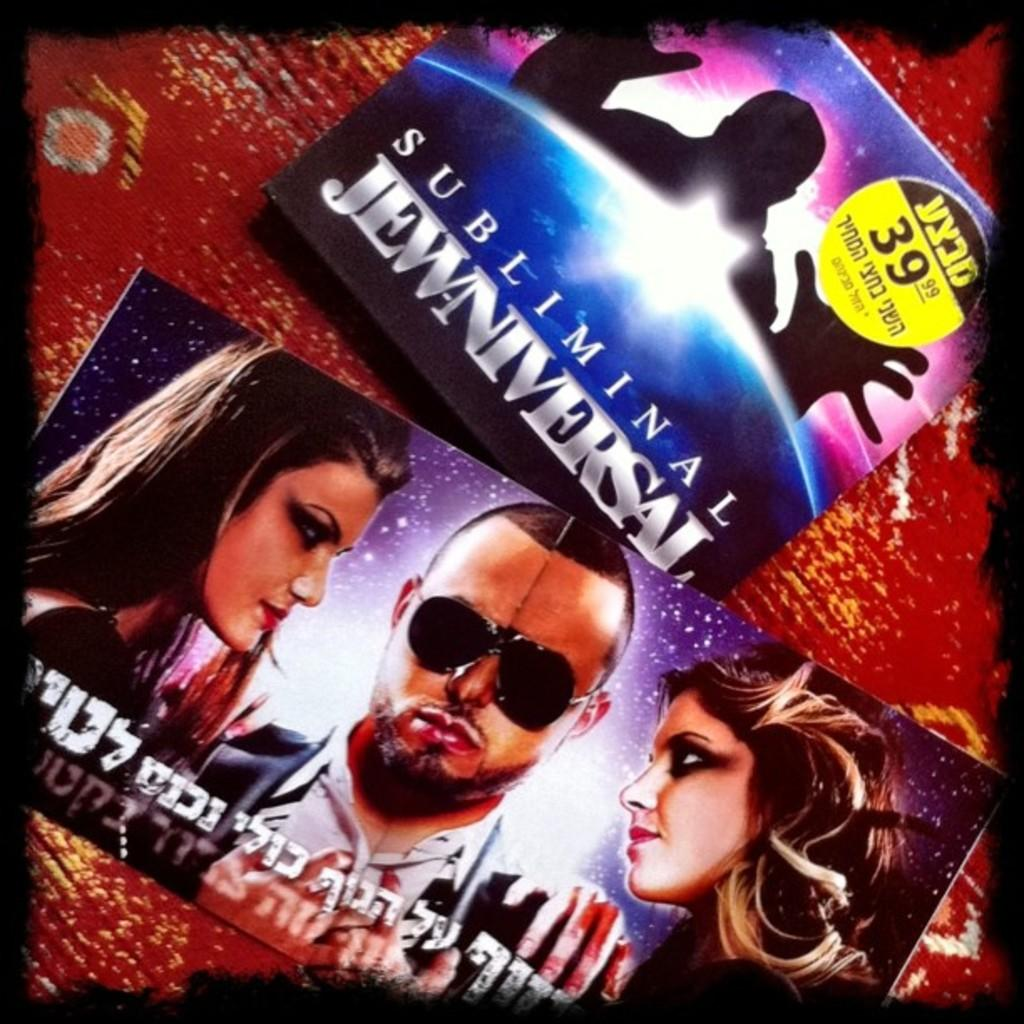What type of image is being described? The image is an edited picture. What objects can be seen in the image? There are cards in the image. What color is the background of the image? The background color is red. How many people are depicted on the cards? There are three people depicted on the cards. What is the aftermath of the cards being rubbed on the ground in the image? There is no mention of cards being rubbed on the ground in the image, so it is not possible to determine the aftermath of such an action. 